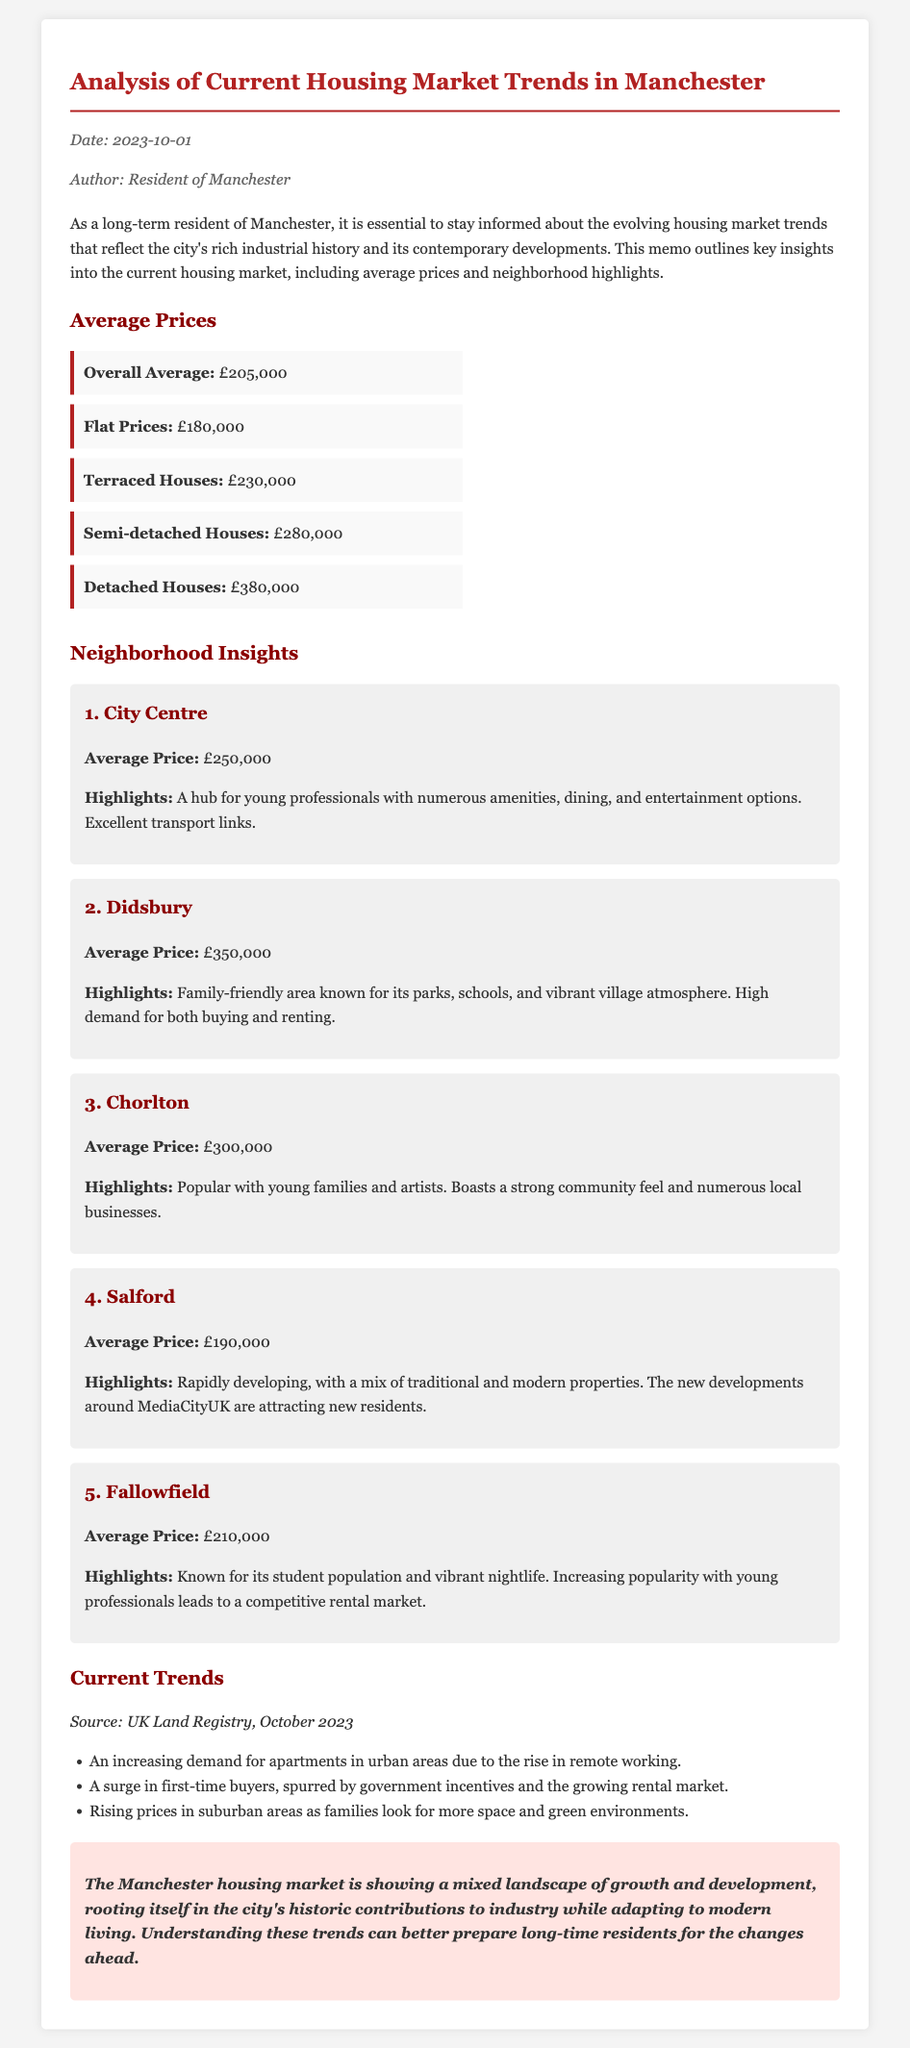what is the overall average house price? The overall average house price is the sum derived from various property types mentioned in the document, which is £205,000.
Answer: £205,000 what is the average price of a semi-detached house? The average price of a semi-detached house is explicitly mentioned in the document as £280,000.
Answer: £280,000 which neighborhood has the highest average price? The neighborhood with the highest average price is identified in the analysis as Didsbury, with an average price of £350,000.
Answer: Didsbury what is the average price of apartments in Manchester? The average price for flats is provided in the document as £180,000.
Answer: £180,000 what notable aspect is highlighted about Salford? The document mentions that Salford is rapidly developing, which highlights a significant change in the neighborhood.
Answer: Rapidly developing how has the demand for apartments changed recently? The document indicates there is an increasing demand for apartments due to the rise in remote working, hence the reasoning here reflects a recent trend.
Answer: Increasing demand what is a reason for rising prices in suburban areas? The document states that rising prices in suburban areas are attributed to families looking for more space and green environments.
Answer: More space and green environments when was this housing market analysis memo dated? The date on the memo is explicitly stated, which is crucial for understanding its timeliness.
Answer: 2023-10-01 what type of document is this? This document is designed as a memo, which is tailored to present information in a concise format related to housing market trends.
Answer: Memo 